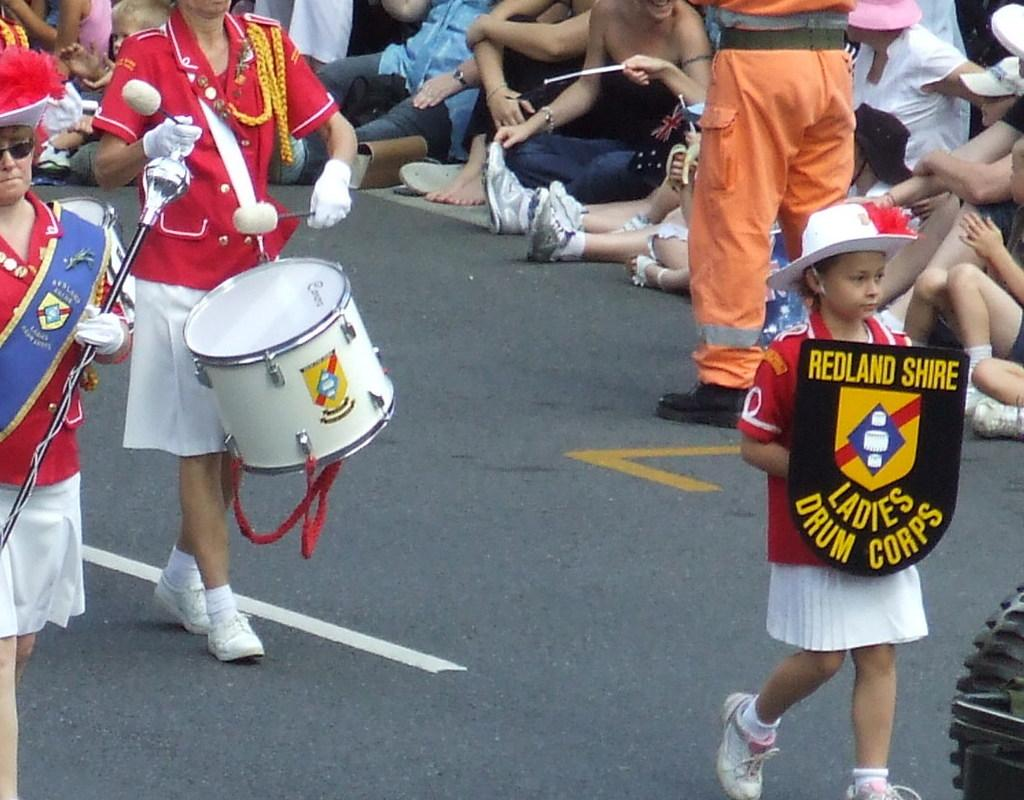Provide a one-sentence caption for the provided image. the name Ladies is on a black shield. 